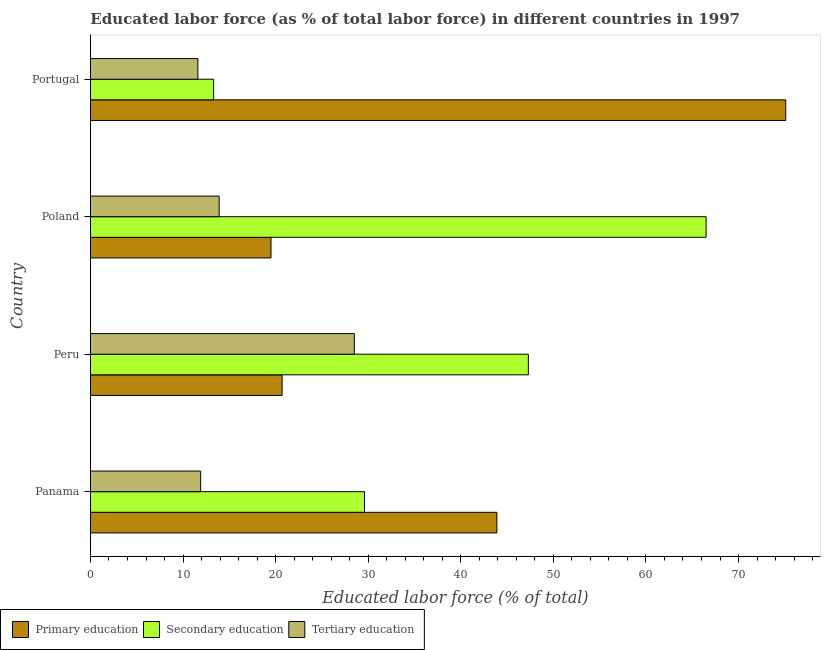How many different coloured bars are there?
Your answer should be very brief. 3. How many groups of bars are there?
Offer a very short reply. 4. Are the number of bars per tick equal to the number of legend labels?
Provide a short and direct response. Yes. Are the number of bars on each tick of the Y-axis equal?
Provide a short and direct response. Yes. How many bars are there on the 3rd tick from the bottom?
Offer a very short reply. 3. What is the label of the 1st group of bars from the top?
Keep it short and to the point. Portugal. In how many cases, is the number of bars for a given country not equal to the number of legend labels?
Keep it short and to the point. 0. What is the percentage of labor force who received primary education in Peru?
Provide a succinct answer. 20.7. Across all countries, what is the minimum percentage of labor force who received tertiary education?
Make the answer very short. 11.6. What is the total percentage of labor force who received tertiary education in the graph?
Your response must be concise. 65.9. What is the difference between the percentage of labor force who received secondary education in Panama and the percentage of labor force who received primary education in Portugal?
Your answer should be compact. -45.5. What is the average percentage of labor force who received tertiary education per country?
Offer a terse response. 16.48. In how many countries, is the percentage of labor force who received primary education greater than 54 %?
Ensure brevity in your answer.  1. What is the ratio of the percentage of labor force who received secondary education in Panama to that in Peru?
Your answer should be compact. 0.63. Is the difference between the percentage of labor force who received primary education in Poland and Portugal greater than the difference between the percentage of labor force who received secondary education in Poland and Portugal?
Provide a short and direct response. No. What is the difference between the highest and the second highest percentage of labor force who received tertiary education?
Your answer should be very brief. 14.6. What is the difference between the highest and the lowest percentage of labor force who received secondary education?
Your response must be concise. 53.2. Is the sum of the percentage of labor force who received secondary education in Panama and Poland greater than the maximum percentage of labor force who received primary education across all countries?
Your response must be concise. Yes. What does the 2nd bar from the top in Portugal represents?
Provide a short and direct response. Secondary education. What does the 2nd bar from the bottom in Poland represents?
Your response must be concise. Secondary education. Is it the case that in every country, the sum of the percentage of labor force who received primary education and percentage of labor force who received secondary education is greater than the percentage of labor force who received tertiary education?
Your answer should be compact. Yes. How many bars are there?
Provide a succinct answer. 12. Are the values on the major ticks of X-axis written in scientific E-notation?
Your answer should be compact. No. Does the graph contain grids?
Keep it short and to the point. No. How many legend labels are there?
Provide a short and direct response. 3. How are the legend labels stacked?
Ensure brevity in your answer.  Horizontal. What is the title of the graph?
Provide a succinct answer. Educated labor force (as % of total labor force) in different countries in 1997. What is the label or title of the X-axis?
Your response must be concise. Educated labor force (% of total). What is the label or title of the Y-axis?
Make the answer very short. Country. What is the Educated labor force (% of total) of Primary education in Panama?
Provide a short and direct response. 43.9. What is the Educated labor force (% of total) of Secondary education in Panama?
Make the answer very short. 29.6. What is the Educated labor force (% of total) of Tertiary education in Panama?
Your answer should be very brief. 11.9. What is the Educated labor force (% of total) in Primary education in Peru?
Your answer should be compact. 20.7. What is the Educated labor force (% of total) of Secondary education in Peru?
Give a very brief answer. 47.3. What is the Educated labor force (% of total) in Primary education in Poland?
Provide a succinct answer. 19.5. What is the Educated labor force (% of total) of Secondary education in Poland?
Your answer should be very brief. 66.5. What is the Educated labor force (% of total) in Tertiary education in Poland?
Your response must be concise. 13.9. What is the Educated labor force (% of total) in Primary education in Portugal?
Ensure brevity in your answer.  75.1. What is the Educated labor force (% of total) in Secondary education in Portugal?
Offer a terse response. 13.3. What is the Educated labor force (% of total) in Tertiary education in Portugal?
Your answer should be very brief. 11.6. Across all countries, what is the maximum Educated labor force (% of total) in Primary education?
Provide a short and direct response. 75.1. Across all countries, what is the maximum Educated labor force (% of total) of Secondary education?
Make the answer very short. 66.5. Across all countries, what is the maximum Educated labor force (% of total) in Tertiary education?
Ensure brevity in your answer.  28.5. Across all countries, what is the minimum Educated labor force (% of total) of Primary education?
Your answer should be very brief. 19.5. Across all countries, what is the minimum Educated labor force (% of total) of Secondary education?
Provide a succinct answer. 13.3. Across all countries, what is the minimum Educated labor force (% of total) of Tertiary education?
Your answer should be very brief. 11.6. What is the total Educated labor force (% of total) in Primary education in the graph?
Keep it short and to the point. 159.2. What is the total Educated labor force (% of total) of Secondary education in the graph?
Offer a very short reply. 156.7. What is the total Educated labor force (% of total) of Tertiary education in the graph?
Your response must be concise. 65.9. What is the difference between the Educated labor force (% of total) in Primary education in Panama and that in Peru?
Give a very brief answer. 23.2. What is the difference between the Educated labor force (% of total) in Secondary education in Panama and that in Peru?
Keep it short and to the point. -17.7. What is the difference between the Educated labor force (% of total) in Tertiary education in Panama and that in Peru?
Keep it short and to the point. -16.6. What is the difference between the Educated labor force (% of total) in Primary education in Panama and that in Poland?
Your answer should be compact. 24.4. What is the difference between the Educated labor force (% of total) in Secondary education in Panama and that in Poland?
Your answer should be compact. -36.9. What is the difference between the Educated labor force (% of total) in Tertiary education in Panama and that in Poland?
Your answer should be compact. -2. What is the difference between the Educated labor force (% of total) in Primary education in Panama and that in Portugal?
Your answer should be very brief. -31.2. What is the difference between the Educated labor force (% of total) of Secondary education in Peru and that in Poland?
Your response must be concise. -19.2. What is the difference between the Educated labor force (% of total) of Primary education in Peru and that in Portugal?
Offer a terse response. -54.4. What is the difference between the Educated labor force (% of total) of Tertiary education in Peru and that in Portugal?
Your answer should be compact. 16.9. What is the difference between the Educated labor force (% of total) in Primary education in Poland and that in Portugal?
Your answer should be very brief. -55.6. What is the difference between the Educated labor force (% of total) of Secondary education in Poland and that in Portugal?
Give a very brief answer. 53.2. What is the difference between the Educated labor force (% of total) of Tertiary education in Poland and that in Portugal?
Ensure brevity in your answer.  2.3. What is the difference between the Educated labor force (% of total) of Primary education in Panama and the Educated labor force (% of total) of Secondary education in Peru?
Your answer should be very brief. -3.4. What is the difference between the Educated labor force (% of total) of Primary education in Panama and the Educated labor force (% of total) of Secondary education in Poland?
Provide a succinct answer. -22.6. What is the difference between the Educated labor force (% of total) of Primary education in Panama and the Educated labor force (% of total) of Tertiary education in Poland?
Give a very brief answer. 30. What is the difference between the Educated labor force (% of total) of Primary education in Panama and the Educated labor force (% of total) of Secondary education in Portugal?
Your answer should be compact. 30.6. What is the difference between the Educated labor force (% of total) in Primary education in Panama and the Educated labor force (% of total) in Tertiary education in Portugal?
Your answer should be compact. 32.3. What is the difference between the Educated labor force (% of total) of Primary education in Peru and the Educated labor force (% of total) of Secondary education in Poland?
Offer a very short reply. -45.8. What is the difference between the Educated labor force (% of total) of Secondary education in Peru and the Educated labor force (% of total) of Tertiary education in Poland?
Provide a short and direct response. 33.4. What is the difference between the Educated labor force (% of total) of Primary education in Peru and the Educated labor force (% of total) of Secondary education in Portugal?
Offer a very short reply. 7.4. What is the difference between the Educated labor force (% of total) in Secondary education in Peru and the Educated labor force (% of total) in Tertiary education in Portugal?
Keep it short and to the point. 35.7. What is the difference between the Educated labor force (% of total) in Primary education in Poland and the Educated labor force (% of total) in Tertiary education in Portugal?
Provide a succinct answer. 7.9. What is the difference between the Educated labor force (% of total) of Secondary education in Poland and the Educated labor force (% of total) of Tertiary education in Portugal?
Keep it short and to the point. 54.9. What is the average Educated labor force (% of total) in Primary education per country?
Make the answer very short. 39.8. What is the average Educated labor force (% of total) in Secondary education per country?
Provide a succinct answer. 39.17. What is the average Educated labor force (% of total) of Tertiary education per country?
Make the answer very short. 16.48. What is the difference between the Educated labor force (% of total) of Secondary education and Educated labor force (% of total) of Tertiary education in Panama?
Provide a short and direct response. 17.7. What is the difference between the Educated labor force (% of total) in Primary education and Educated labor force (% of total) in Secondary education in Peru?
Your answer should be compact. -26.6. What is the difference between the Educated labor force (% of total) of Primary education and Educated labor force (% of total) of Secondary education in Poland?
Offer a very short reply. -47. What is the difference between the Educated labor force (% of total) of Primary education and Educated labor force (% of total) of Tertiary education in Poland?
Ensure brevity in your answer.  5.6. What is the difference between the Educated labor force (% of total) of Secondary education and Educated labor force (% of total) of Tertiary education in Poland?
Give a very brief answer. 52.6. What is the difference between the Educated labor force (% of total) in Primary education and Educated labor force (% of total) in Secondary education in Portugal?
Keep it short and to the point. 61.8. What is the difference between the Educated labor force (% of total) in Primary education and Educated labor force (% of total) in Tertiary education in Portugal?
Keep it short and to the point. 63.5. What is the difference between the Educated labor force (% of total) in Secondary education and Educated labor force (% of total) in Tertiary education in Portugal?
Give a very brief answer. 1.7. What is the ratio of the Educated labor force (% of total) of Primary education in Panama to that in Peru?
Your response must be concise. 2.12. What is the ratio of the Educated labor force (% of total) of Secondary education in Panama to that in Peru?
Your answer should be very brief. 0.63. What is the ratio of the Educated labor force (% of total) of Tertiary education in Panama to that in Peru?
Offer a terse response. 0.42. What is the ratio of the Educated labor force (% of total) in Primary education in Panama to that in Poland?
Your answer should be very brief. 2.25. What is the ratio of the Educated labor force (% of total) in Secondary education in Panama to that in Poland?
Keep it short and to the point. 0.45. What is the ratio of the Educated labor force (% of total) in Tertiary education in Panama to that in Poland?
Give a very brief answer. 0.86. What is the ratio of the Educated labor force (% of total) in Primary education in Panama to that in Portugal?
Keep it short and to the point. 0.58. What is the ratio of the Educated labor force (% of total) in Secondary education in Panama to that in Portugal?
Offer a very short reply. 2.23. What is the ratio of the Educated labor force (% of total) of Tertiary education in Panama to that in Portugal?
Offer a terse response. 1.03. What is the ratio of the Educated labor force (% of total) of Primary education in Peru to that in Poland?
Offer a terse response. 1.06. What is the ratio of the Educated labor force (% of total) of Secondary education in Peru to that in Poland?
Offer a very short reply. 0.71. What is the ratio of the Educated labor force (% of total) of Tertiary education in Peru to that in Poland?
Ensure brevity in your answer.  2.05. What is the ratio of the Educated labor force (% of total) of Primary education in Peru to that in Portugal?
Your answer should be compact. 0.28. What is the ratio of the Educated labor force (% of total) of Secondary education in Peru to that in Portugal?
Your answer should be very brief. 3.56. What is the ratio of the Educated labor force (% of total) of Tertiary education in Peru to that in Portugal?
Make the answer very short. 2.46. What is the ratio of the Educated labor force (% of total) of Primary education in Poland to that in Portugal?
Offer a very short reply. 0.26. What is the ratio of the Educated labor force (% of total) in Secondary education in Poland to that in Portugal?
Keep it short and to the point. 5. What is the ratio of the Educated labor force (% of total) of Tertiary education in Poland to that in Portugal?
Offer a terse response. 1.2. What is the difference between the highest and the second highest Educated labor force (% of total) in Primary education?
Make the answer very short. 31.2. What is the difference between the highest and the second highest Educated labor force (% of total) in Tertiary education?
Offer a terse response. 14.6. What is the difference between the highest and the lowest Educated labor force (% of total) in Primary education?
Offer a terse response. 55.6. What is the difference between the highest and the lowest Educated labor force (% of total) in Secondary education?
Your answer should be compact. 53.2. What is the difference between the highest and the lowest Educated labor force (% of total) of Tertiary education?
Provide a succinct answer. 16.9. 